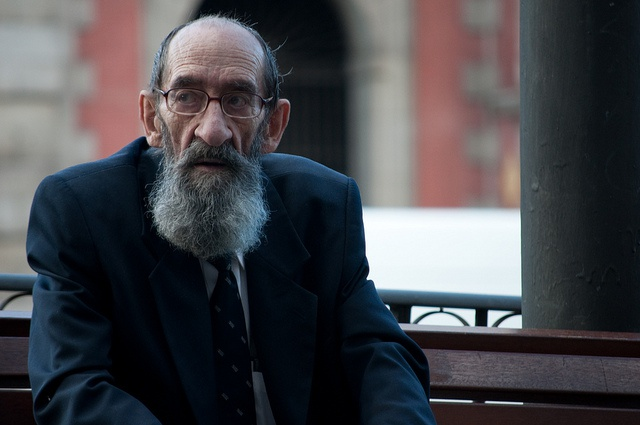Describe the objects in this image and their specific colors. I can see people in gray, black, darkblue, and blue tones, bench in gray and black tones, and tie in gray, black, darkblue, and blue tones in this image. 